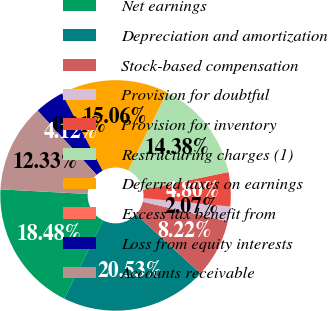Convert chart to OTSL. <chart><loc_0><loc_0><loc_500><loc_500><pie_chart><fcel>Net earnings<fcel>Depreciation and amortization<fcel>Stock-based compensation<fcel>Provision for doubtful<fcel>Provision for inventory<fcel>Restructuring charges (1)<fcel>Deferred taxes on earnings<fcel>Excess tax benefit from<fcel>Loss from equity interests<fcel>Accounts receivable<nl><fcel>18.48%<fcel>20.53%<fcel>8.22%<fcel>2.07%<fcel>4.8%<fcel>14.38%<fcel>15.06%<fcel>0.01%<fcel>4.12%<fcel>12.33%<nl></chart> 